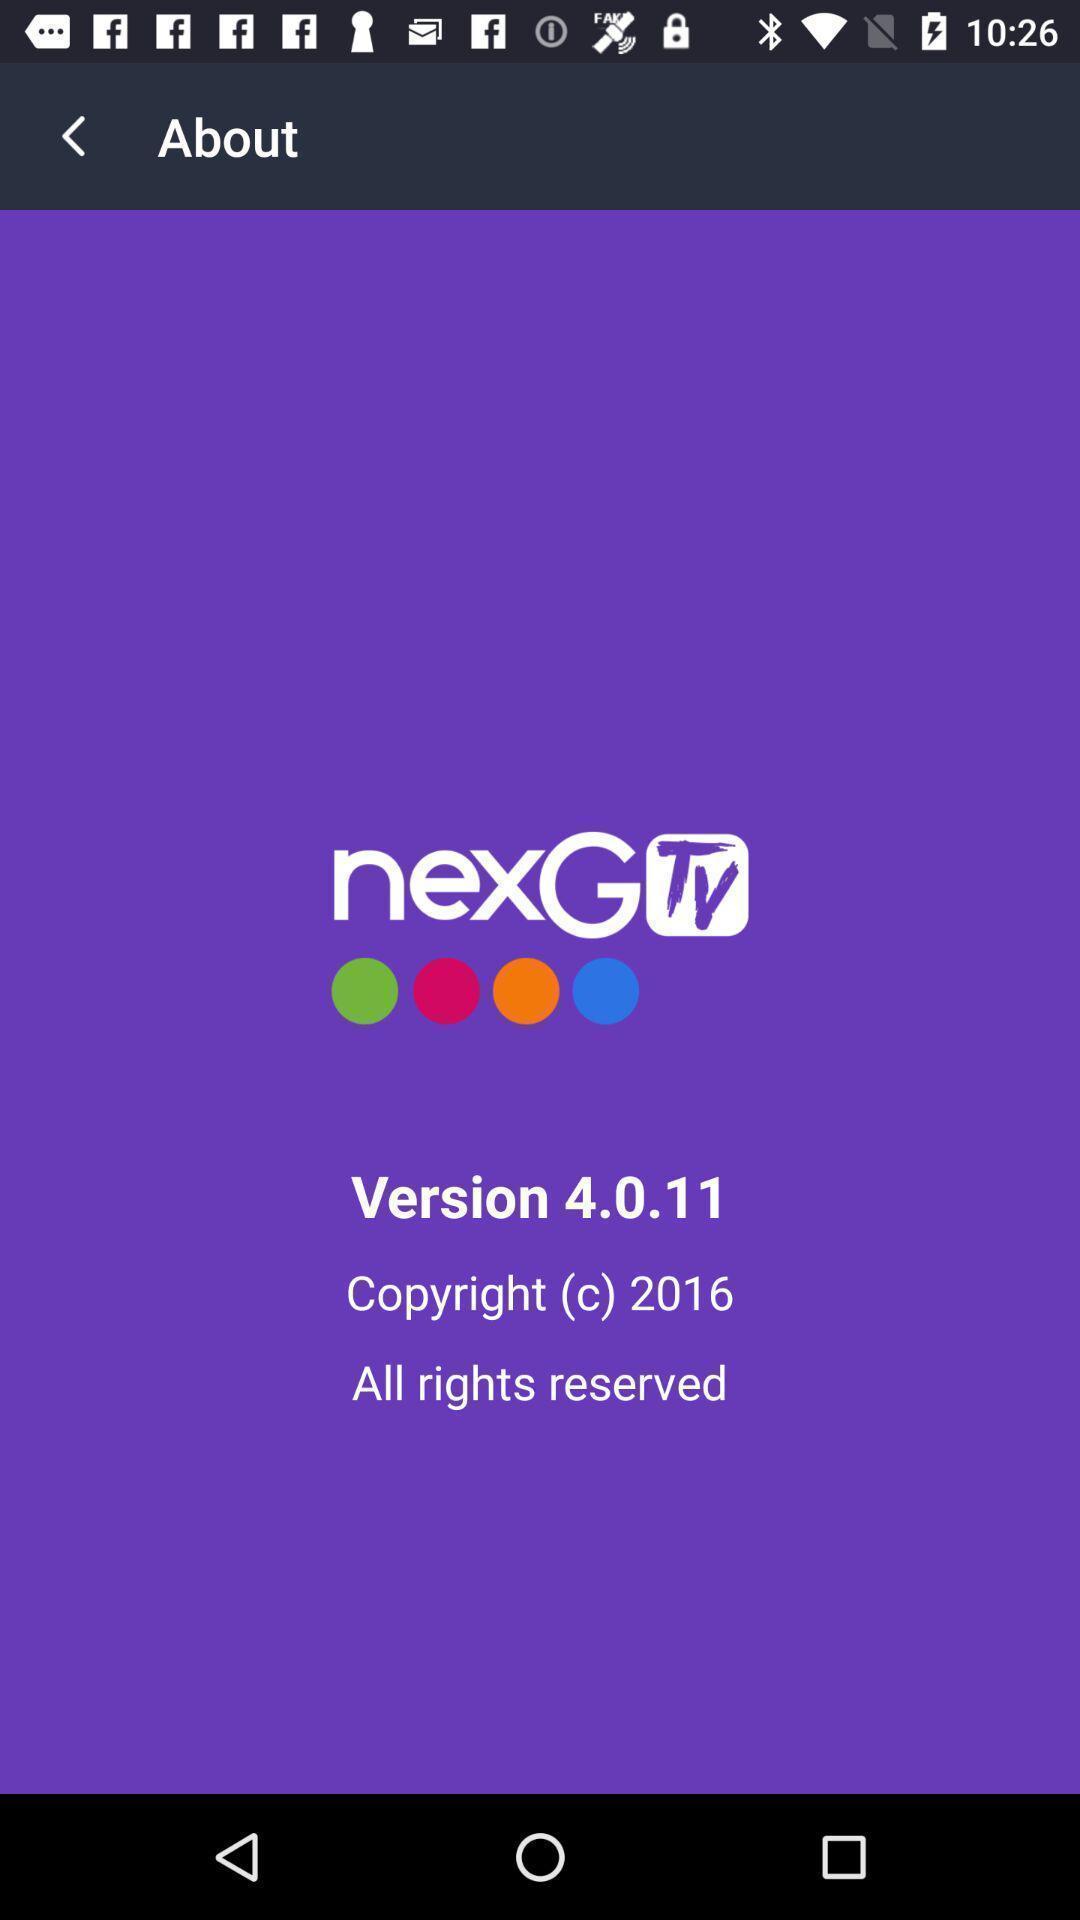Tell me about the visual elements in this screen capture. Screen shows about an entertainment app. 